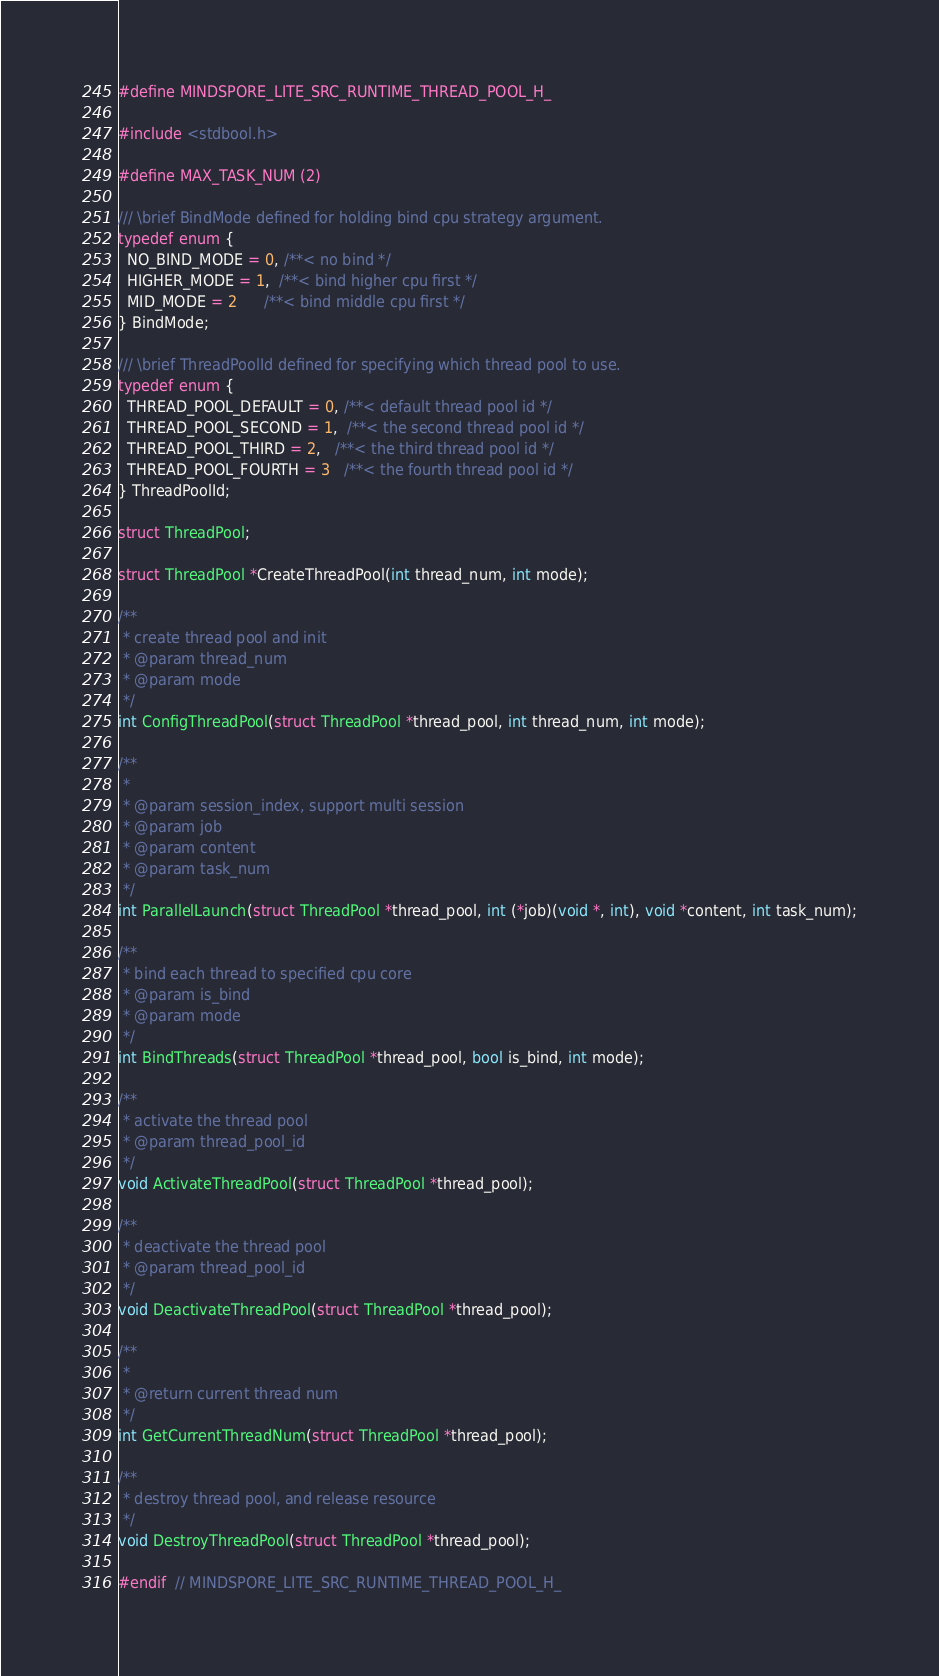<code> <loc_0><loc_0><loc_500><loc_500><_C_>#define MINDSPORE_LITE_SRC_RUNTIME_THREAD_POOL_H_

#include <stdbool.h>

#define MAX_TASK_NUM (2)

/// \brief BindMode defined for holding bind cpu strategy argument.
typedef enum {
  NO_BIND_MODE = 0, /**< no bind */
  HIGHER_MODE = 1,  /**< bind higher cpu first */
  MID_MODE = 2      /**< bind middle cpu first */
} BindMode;

/// \brief ThreadPoolId defined for specifying which thread pool to use.
typedef enum {
  THREAD_POOL_DEFAULT = 0, /**< default thread pool id */
  THREAD_POOL_SECOND = 1,  /**< the second thread pool id */
  THREAD_POOL_THIRD = 2,   /**< the third thread pool id */
  THREAD_POOL_FOURTH = 3   /**< the fourth thread pool id */
} ThreadPoolId;

struct ThreadPool;

struct ThreadPool *CreateThreadPool(int thread_num, int mode);

/**
 * create thread pool and init
 * @param thread_num
 * @param mode
 */
int ConfigThreadPool(struct ThreadPool *thread_pool, int thread_num, int mode);

/**
 *
 * @param session_index, support multi session
 * @param job
 * @param content
 * @param task_num
 */
int ParallelLaunch(struct ThreadPool *thread_pool, int (*job)(void *, int), void *content, int task_num);

/**
 * bind each thread to specified cpu core
 * @param is_bind
 * @param mode
 */
int BindThreads(struct ThreadPool *thread_pool, bool is_bind, int mode);

/**
 * activate the thread pool
 * @param thread_pool_id
 */
void ActivateThreadPool(struct ThreadPool *thread_pool);

/**
 * deactivate the thread pool
 * @param thread_pool_id
 */
void DeactivateThreadPool(struct ThreadPool *thread_pool);

/**
 *
 * @return current thread num
 */
int GetCurrentThreadNum(struct ThreadPool *thread_pool);

/**
 * destroy thread pool, and release resource
 */
void DestroyThreadPool(struct ThreadPool *thread_pool);

#endif  // MINDSPORE_LITE_SRC_RUNTIME_THREAD_POOL_H_
</code> 